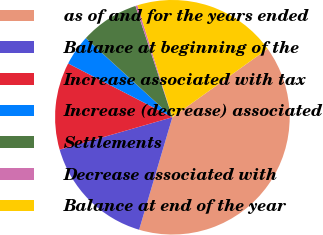<chart> <loc_0><loc_0><loc_500><loc_500><pie_chart><fcel>as of and for the years ended<fcel>Balance at beginning of the<fcel>Increase associated with tax<fcel>Increase (decrease) associated<fcel>Settlements<fcel>Decrease associated with<fcel>Balance at end of the year<nl><fcel>39.5%<fcel>15.97%<fcel>12.04%<fcel>4.2%<fcel>8.12%<fcel>0.28%<fcel>19.89%<nl></chart> 